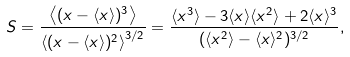Convert formula to latex. <formula><loc_0><loc_0><loc_500><loc_500>S = \frac { \left \langle ( x - \langle x \rangle ) ^ { 3 } \right \rangle } { \left \langle ( x - \langle x \rangle ) ^ { 2 } \right \rangle ^ { 3 / 2 } } = \frac { \langle x ^ { 3 } \rangle - 3 \langle x \rangle \langle x ^ { 2 } \rangle + 2 \langle x \rangle ^ { 3 } } { ( \langle x ^ { 2 } \rangle - \langle x \rangle ^ { 2 } ) ^ { 3 / 2 } } ,</formula> 